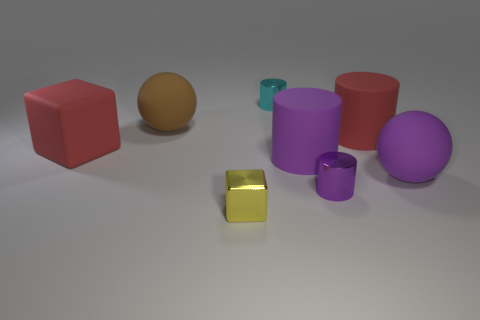What number of other things are the same size as the purple matte cylinder?
Provide a succinct answer. 4. Are there any purple rubber cubes that have the same size as the purple matte sphere?
Ensure brevity in your answer.  No. Does the shiny thing to the right of the tiny cyan shiny cylinder have the same size as the red object to the left of the big purple cylinder?
Your response must be concise. No. What is the shape of the large red rubber object that is behind the block that is behind the large purple cylinder?
Give a very brief answer. Cylinder. There is a large brown ball; how many tiny cyan cylinders are behind it?
Your response must be concise. 1. There is a cube that is made of the same material as the large brown object; what color is it?
Your answer should be compact. Red. There is a purple sphere; is it the same size as the cylinder that is behind the large brown matte thing?
Make the answer very short. No. There is a ball that is on the left side of the purple rubber thing that is to the left of the sphere on the right side of the yellow object; what is its size?
Give a very brief answer. Large. What number of matte things are either large purple things or large brown blocks?
Provide a short and direct response. 2. There is a rubber sphere on the right side of the yellow object; what is its color?
Give a very brief answer. Purple. 